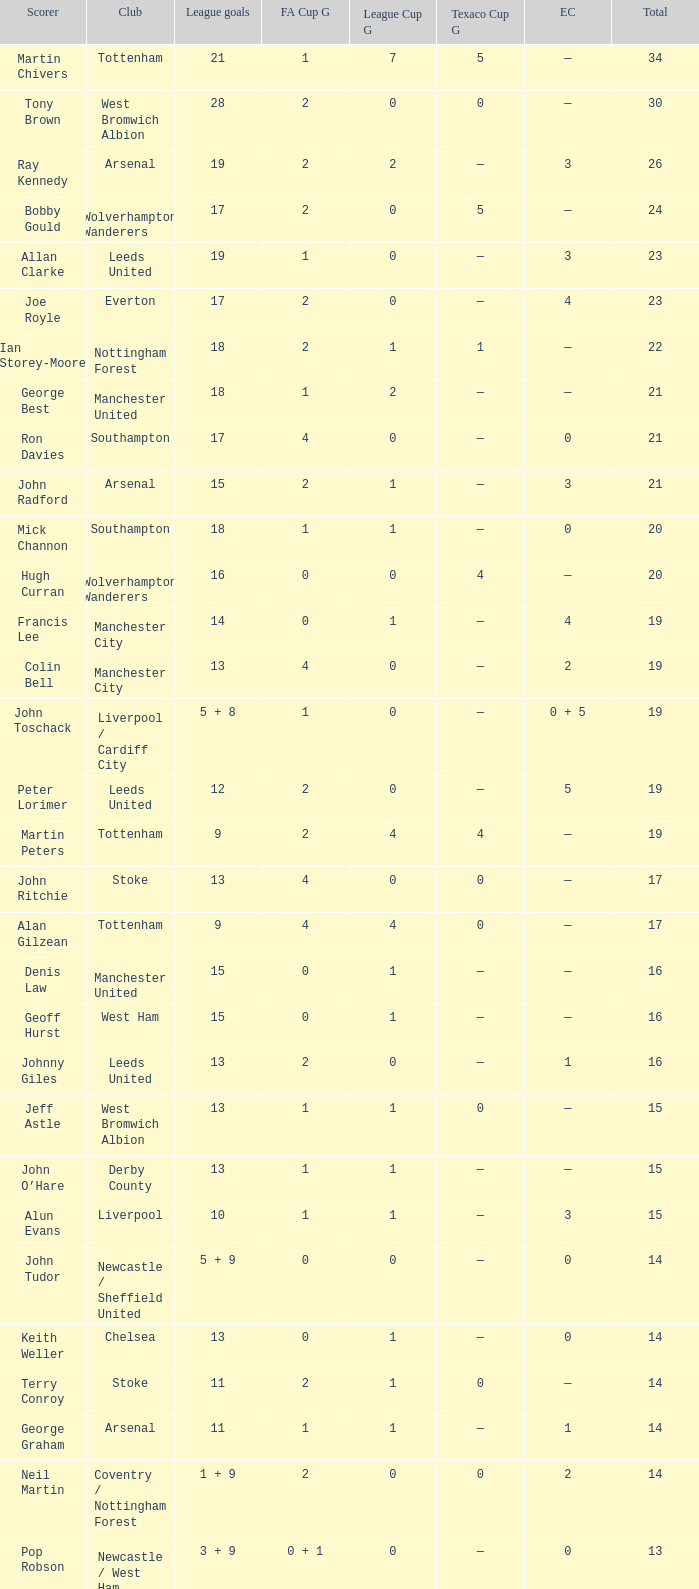What is FA Cup Goals, when Euro Competitions is 1, and when League Goals is 11? 1.0. 